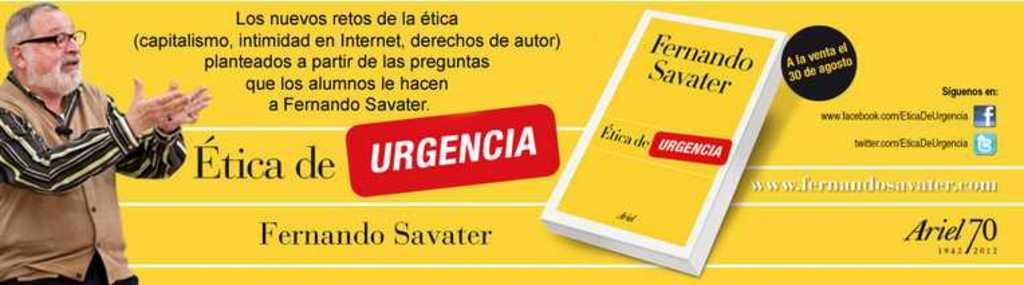<image>
Provide a brief description of the given image. An advertisement featuring author and speaker Fernando Savater. 